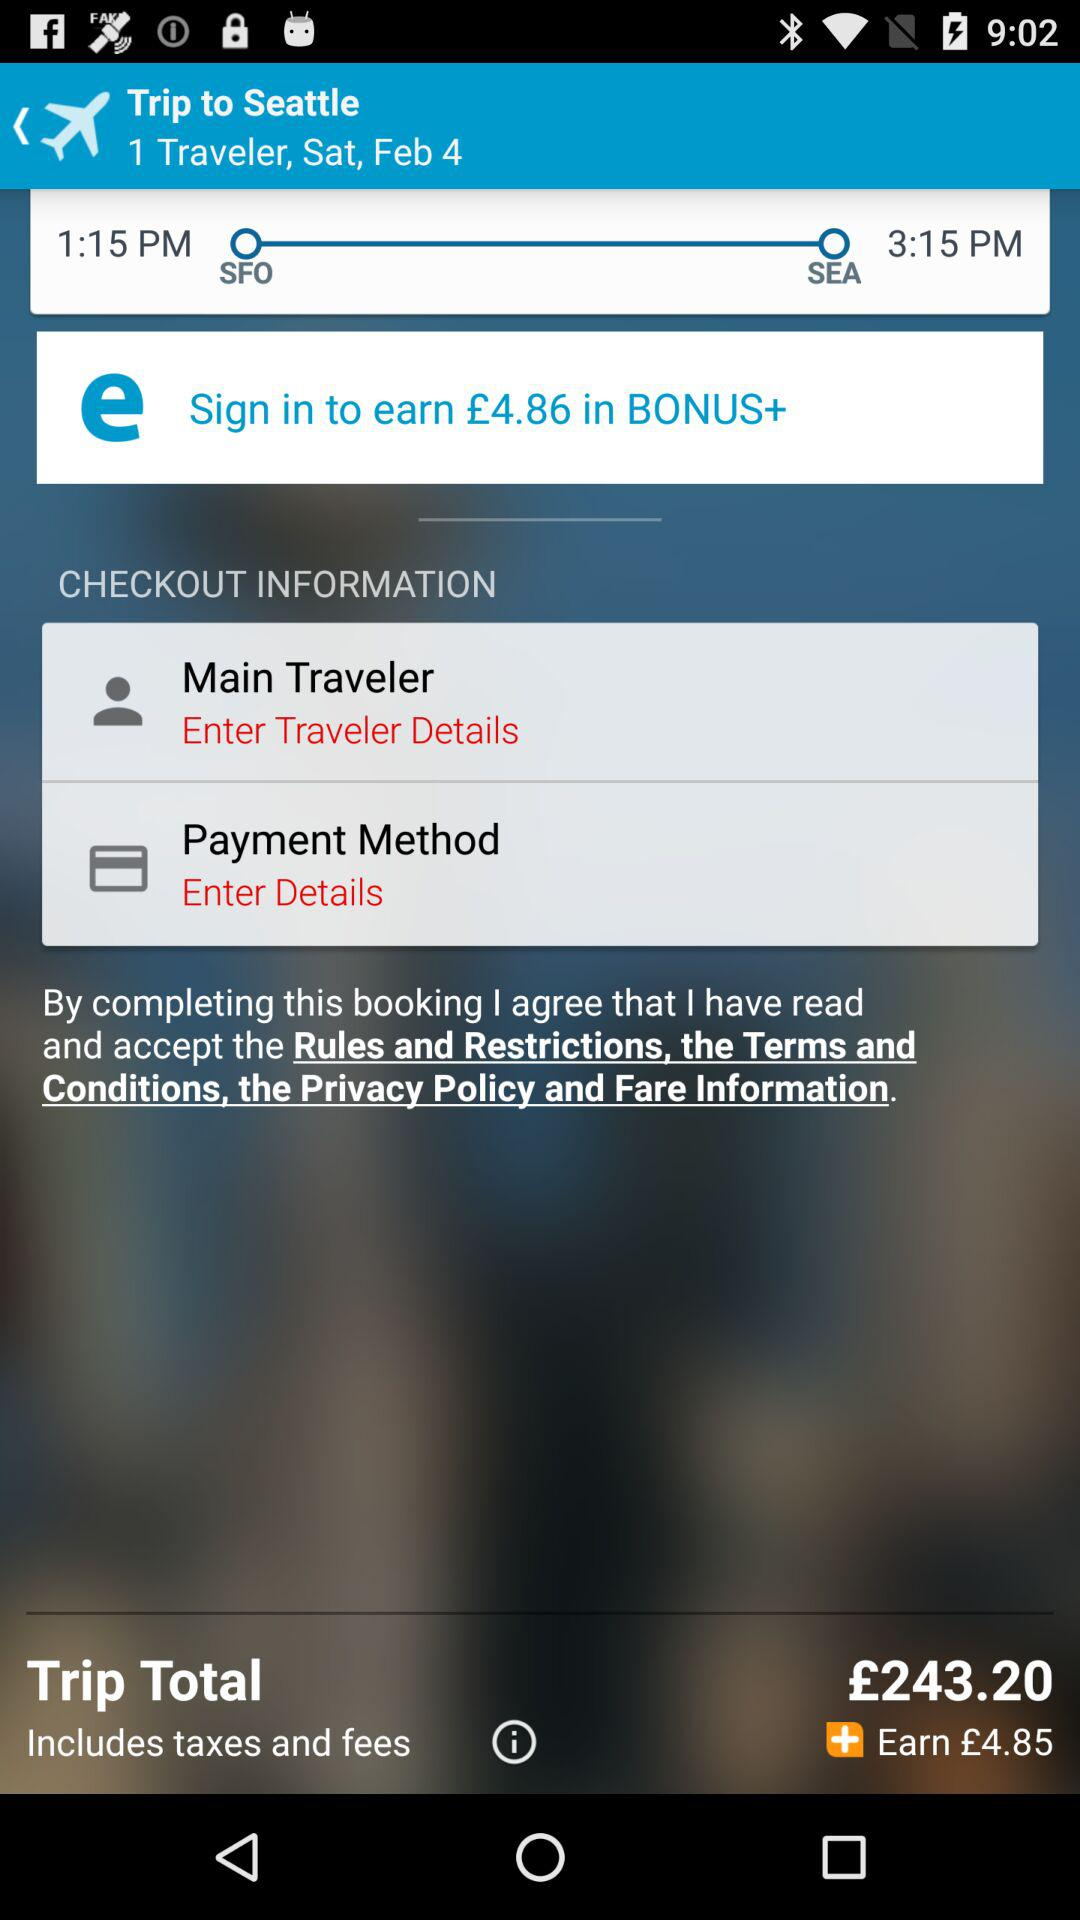What is the total trip fare? The total trip fare is £243.20. 